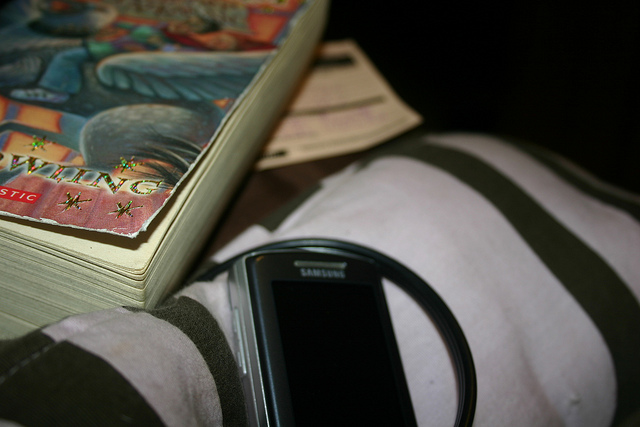Read and extract the text from this image. WRING STIC SAMSUNG 